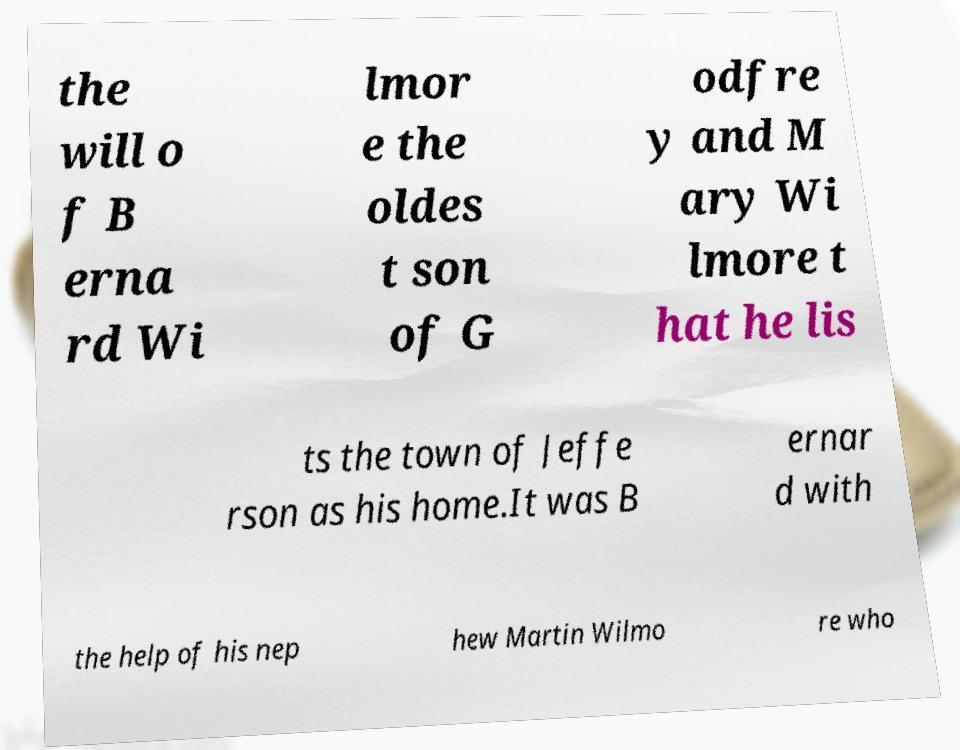I need the written content from this picture converted into text. Can you do that? the will o f B erna rd Wi lmor e the oldes t son of G odfre y and M ary Wi lmore t hat he lis ts the town of Jeffe rson as his home.It was B ernar d with the help of his nep hew Martin Wilmo re who 